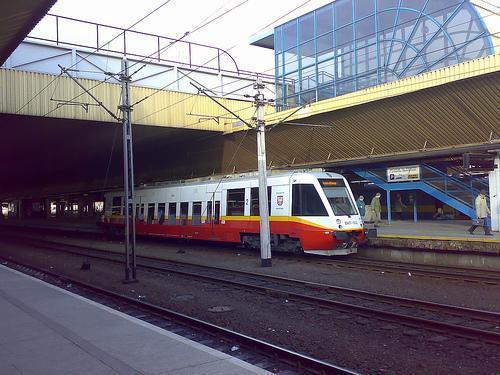How many trains are there?
Give a very brief answer. 1. 